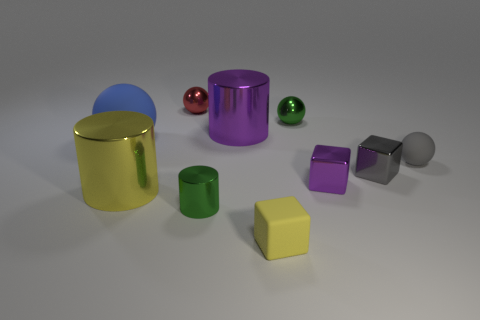What colors are the spherical objects in this image? The spherical objects come in red and green colors. 